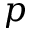<formula> <loc_0><loc_0><loc_500><loc_500>p</formula> 